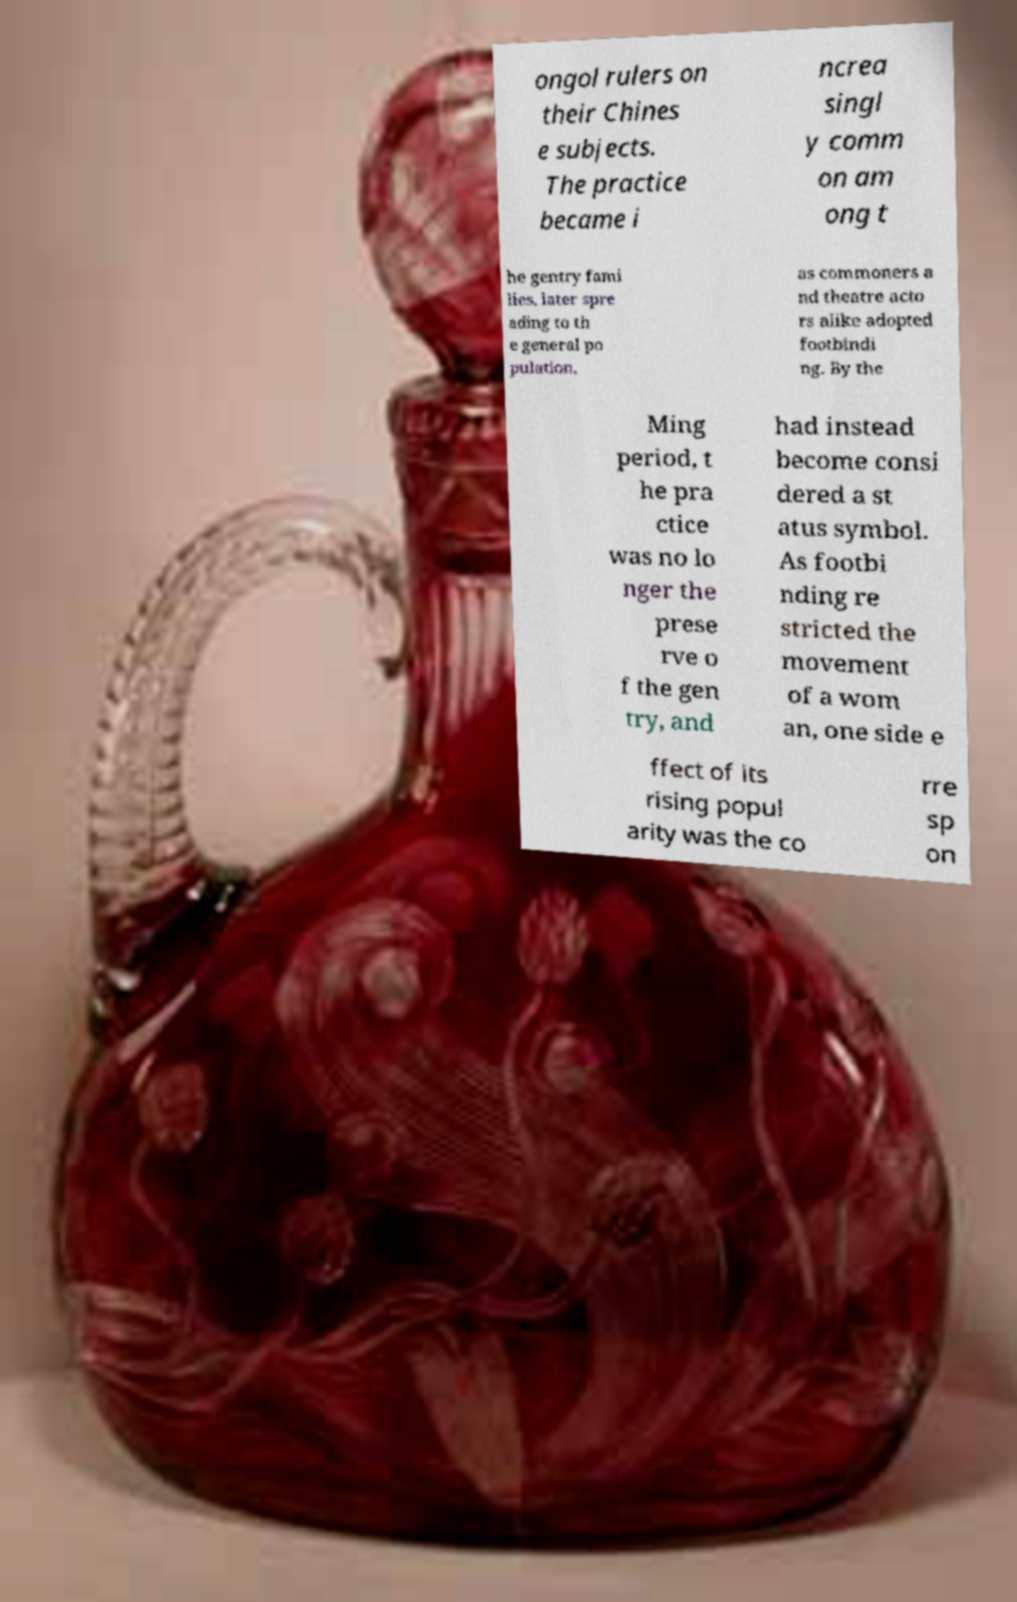Can you accurately transcribe the text from the provided image for me? ongol rulers on their Chines e subjects. The practice became i ncrea singl y comm on am ong t he gentry fami lies, later spre ading to th e general po pulation, as commoners a nd theatre acto rs alike adopted footbindi ng. By the Ming period, t he pra ctice was no lo nger the prese rve o f the gen try, and had instead become consi dered a st atus symbol. As footbi nding re stricted the movement of a wom an, one side e ffect of its rising popul arity was the co rre sp on 